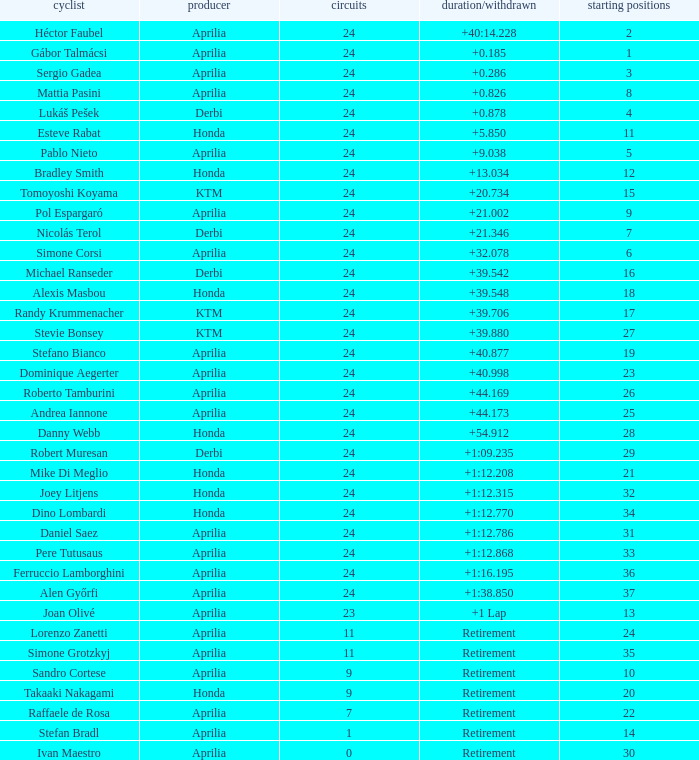Who manufactured the motorcycle that did 24 laps and 9 grids? Aprilia. 